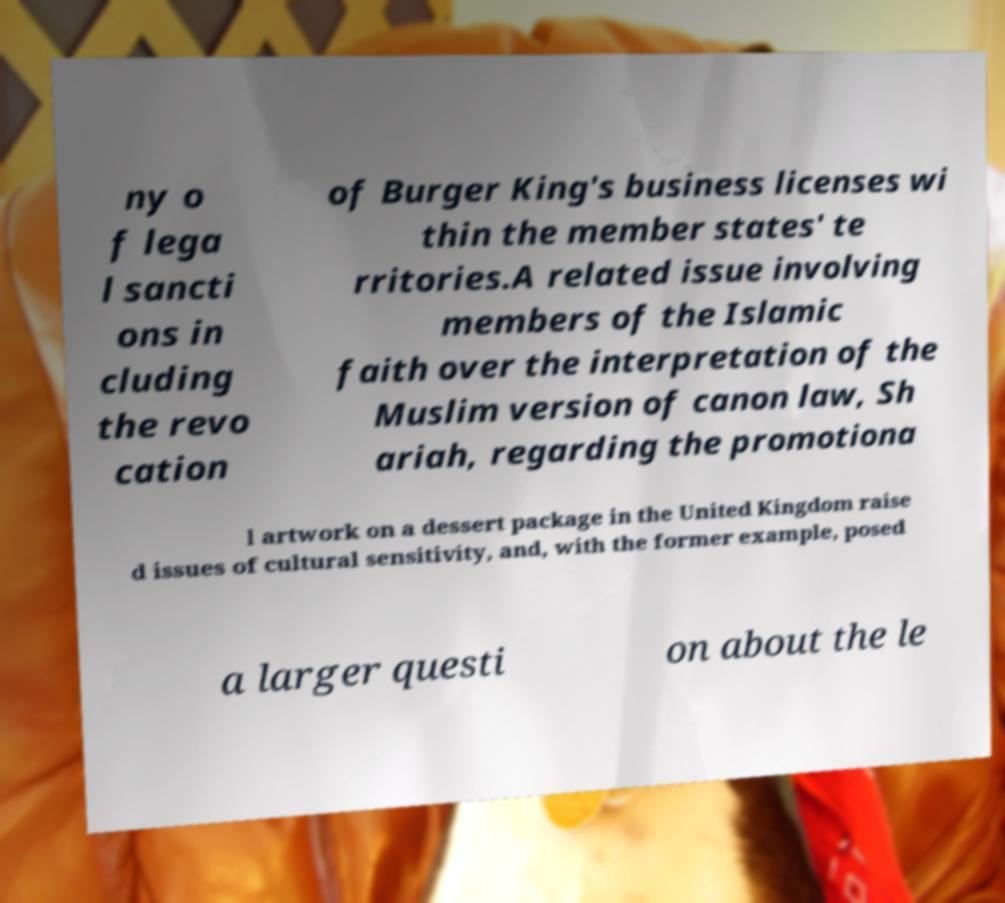Please identify and transcribe the text found in this image. ny o f lega l sancti ons in cluding the revo cation of Burger King's business licenses wi thin the member states' te rritories.A related issue involving members of the Islamic faith over the interpretation of the Muslim version of canon law, Sh ariah, regarding the promotiona l artwork on a dessert package in the United Kingdom raise d issues of cultural sensitivity, and, with the former example, posed a larger questi on about the le 